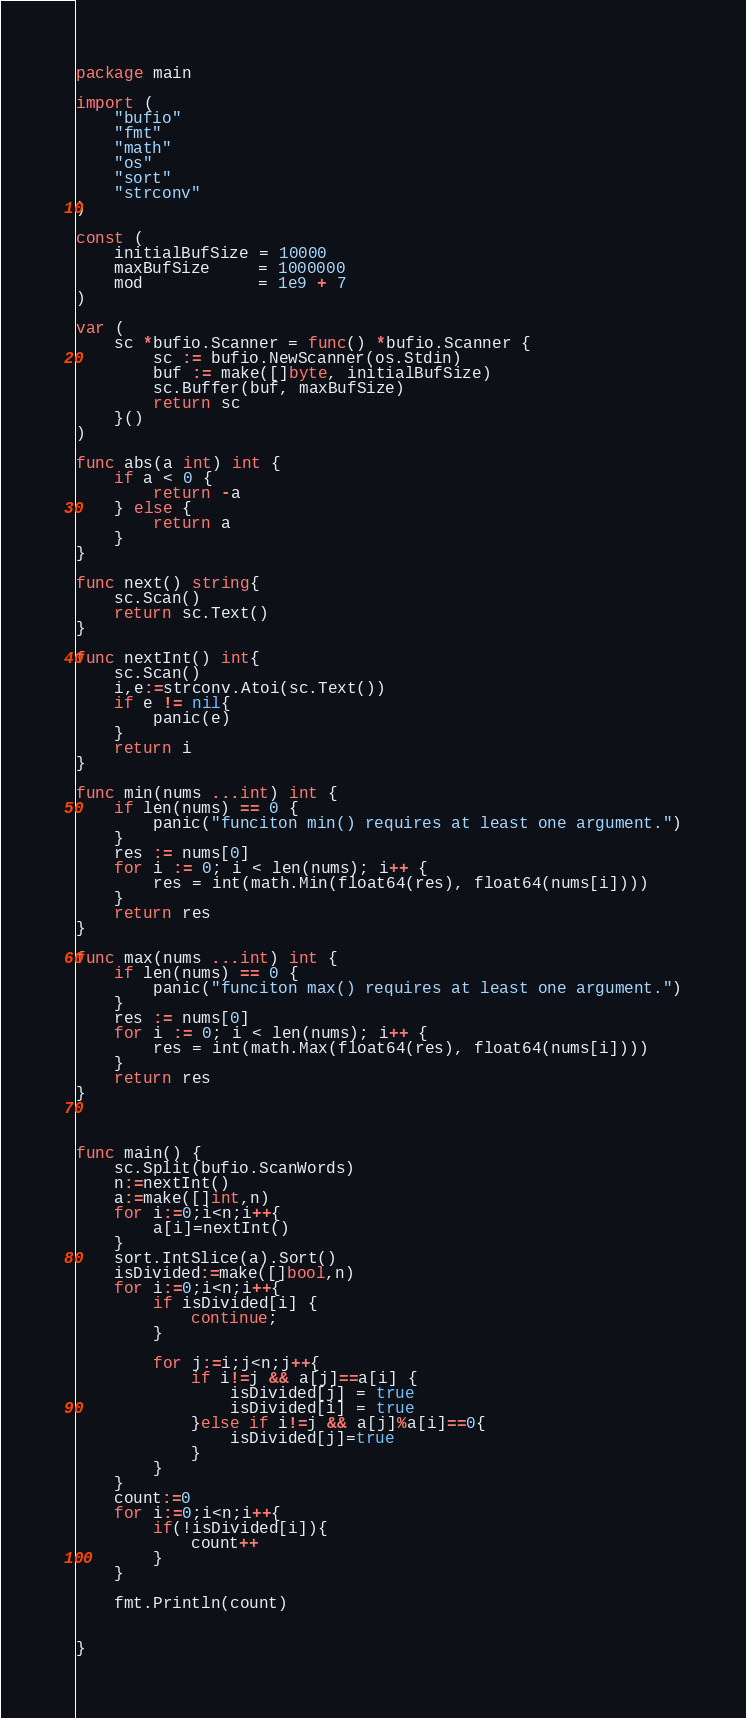Convert code to text. <code><loc_0><loc_0><loc_500><loc_500><_Go_>package main

import (
	"bufio"
	"fmt"
	"math"
	"os"
	"sort"
	"strconv"
)

const (
	initialBufSize = 10000
	maxBufSize     = 1000000
	mod            = 1e9 + 7
)

var (
	sc *bufio.Scanner = func() *bufio.Scanner {
		sc := bufio.NewScanner(os.Stdin)
		buf := make([]byte, initialBufSize)
		sc.Buffer(buf, maxBufSize)
		return sc
	}()
)

func abs(a int) int {
	if a < 0 {
		return -a
	} else {
		return a
	}
}

func next() string{
	sc.Scan()
	return sc.Text()
}

func nextInt() int{
	sc.Scan()
	i,e:=strconv.Atoi(sc.Text())
	if e != nil{
		panic(e)
	}
	return i
}

func min(nums ...int) int {
	if len(nums) == 0 {
		panic("funciton min() requires at least one argument.")
	}
	res := nums[0]
	for i := 0; i < len(nums); i++ {
		res = int(math.Min(float64(res), float64(nums[i])))
	}
	return res
}

func max(nums ...int) int {
	if len(nums) == 0 {
		panic("funciton max() requires at least one argument.")
	}
	res := nums[0]
	for i := 0; i < len(nums); i++ {
		res = int(math.Max(float64(res), float64(nums[i])))
	}
	return res
}



func main() {
	sc.Split(bufio.ScanWords)
	n:=nextInt()
	a:=make([]int,n)
	for i:=0;i<n;i++{
		a[i]=nextInt()
	}
	sort.IntSlice(a).Sort()
	isDivided:=make([]bool,n)
	for i:=0;i<n;i++{
		if isDivided[i] {
			continue;
		}

		for j:=i;j<n;j++{
			if i!=j && a[j]==a[i] {
				isDivided[j] = true
				isDivided[i] = true
			}else if i!=j && a[j]%a[i]==0{
				isDivided[j]=true
			}
		}
	}
	count:=0
	for i:=0;i<n;i++{
		if(!isDivided[i]){
			count++
		}
	}

	fmt.Println(count)


}
</code> 